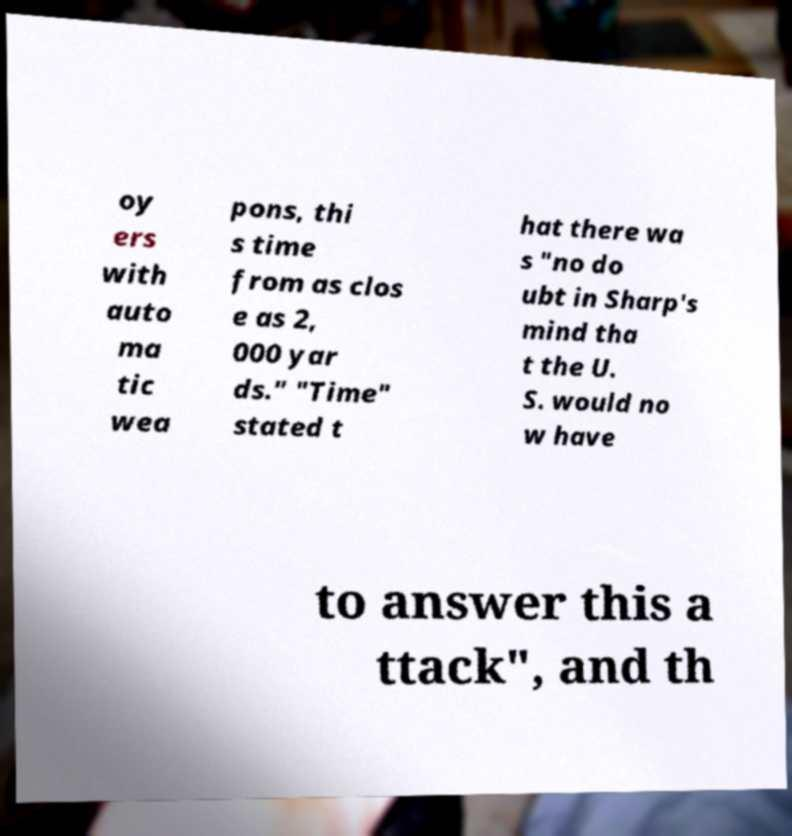There's text embedded in this image that I need extracted. Can you transcribe it verbatim? oy ers with auto ma tic wea pons, thi s time from as clos e as 2, 000 yar ds." "Time" stated t hat there wa s "no do ubt in Sharp's mind tha t the U. S. would no w have to answer this a ttack", and th 